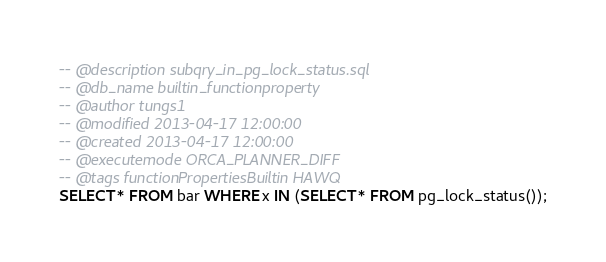<code> <loc_0><loc_0><loc_500><loc_500><_SQL_>-- @description subqry_in_pg_lock_status.sql
-- @db_name builtin_functionproperty
-- @author tungs1
-- @modified 2013-04-17 12:00:00
-- @created 2013-04-17 12:00:00
-- @executemode ORCA_PLANNER_DIFF
-- @tags functionPropertiesBuiltin HAWQ
SELECT * FROM bar WHERE x IN (SELECT * FROM pg_lock_status());
</code> 